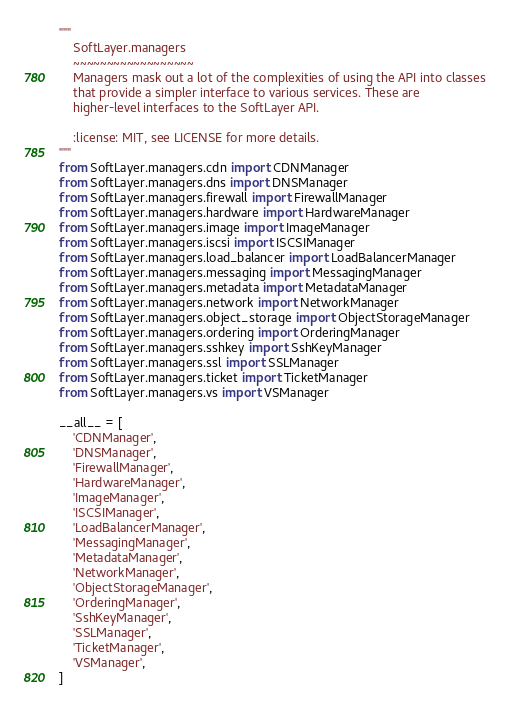Convert code to text. <code><loc_0><loc_0><loc_500><loc_500><_Python_>"""
    SoftLayer.managers
    ~~~~~~~~~~~~~~~~~~
    Managers mask out a lot of the complexities of using the API into classes
    that provide a simpler interface to various services. These are
    higher-level interfaces to the SoftLayer API.

    :license: MIT, see LICENSE for more details.
"""
from SoftLayer.managers.cdn import CDNManager
from SoftLayer.managers.dns import DNSManager
from SoftLayer.managers.firewall import FirewallManager
from SoftLayer.managers.hardware import HardwareManager
from SoftLayer.managers.image import ImageManager
from SoftLayer.managers.iscsi import ISCSIManager
from SoftLayer.managers.load_balancer import LoadBalancerManager
from SoftLayer.managers.messaging import MessagingManager
from SoftLayer.managers.metadata import MetadataManager
from SoftLayer.managers.network import NetworkManager
from SoftLayer.managers.object_storage import ObjectStorageManager
from SoftLayer.managers.ordering import OrderingManager
from SoftLayer.managers.sshkey import SshKeyManager
from SoftLayer.managers.ssl import SSLManager
from SoftLayer.managers.ticket import TicketManager
from SoftLayer.managers.vs import VSManager

__all__ = [
    'CDNManager',
    'DNSManager',
    'FirewallManager',
    'HardwareManager',
    'ImageManager',
    'ISCSIManager',
    'LoadBalancerManager',
    'MessagingManager',
    'MetadataManager',
    'NetworkManager',
    'ObjectStorageManager',
    'OrderingManager',
    'SshKeyManager',
    'SSLManager',
    'TicketManager',
    'VSManager',
]
</code> 